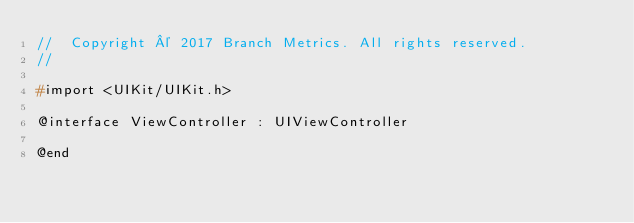Convert code to text. <code><loc_0><loc_0><loc_500><loc_500><_C_>//  Copyright © 2017 Branch Metrics. All rights reserved.
//

#import <UIKit/UIKit.h>

@interface ViewController : UIViewController

@end

</code> 